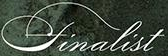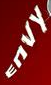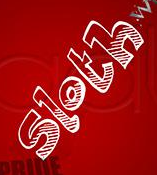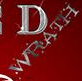Read the text content from these images in order, separated by a semicolon. finalist; ENVY; sloth; WRATH 